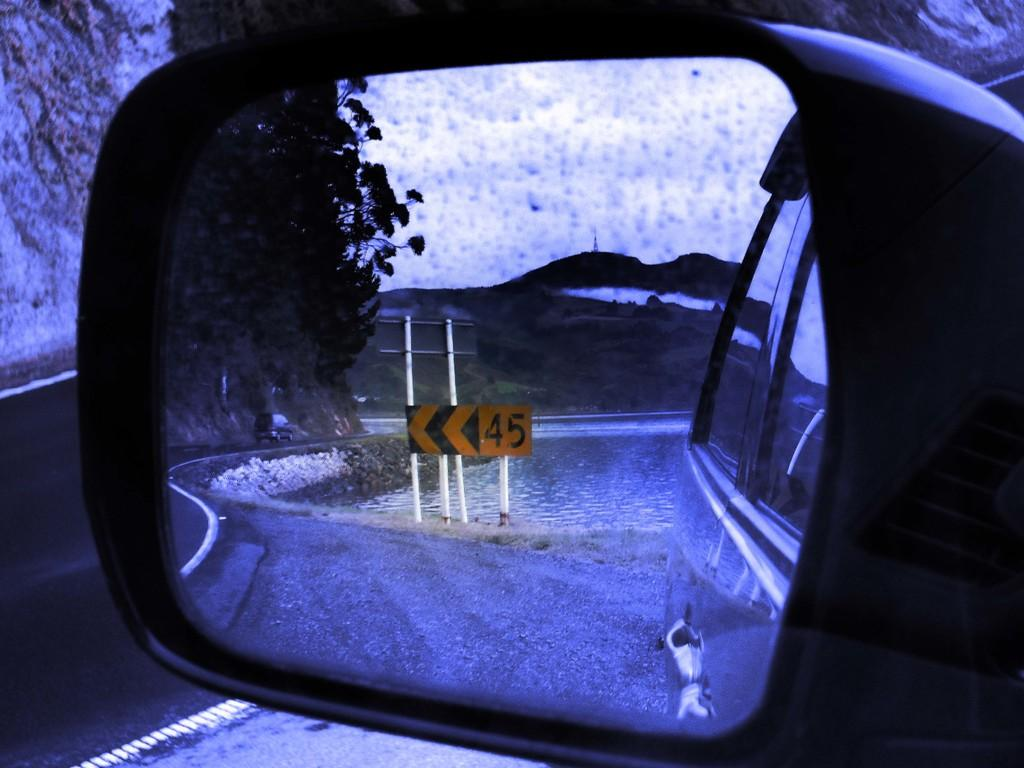What object in the image reflects its surroundings? There is a mirror in the image that reflects its surroundings. What specific elements can be seen in the mirror's reflection? The mirror reflects poles, a board, water, plants, a mountain, and the sky. How does the organization of the poles change in the mirror's reflection? There is no mention of an organization in the image or its reflection, and the poles' arrangement remains the same in the mirror's reflection. Can you see a glove in the mirror's reflection? There is no glove present in the image or its reflection. 